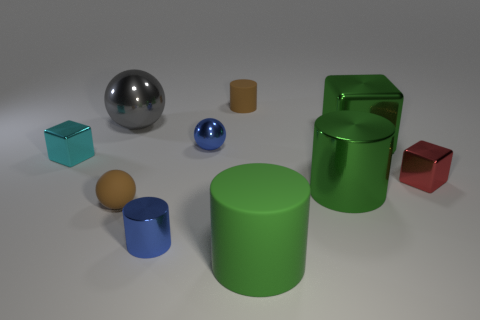Subtract all brown cylinders. How many cylinders are left? 3 Subtract all brown cylinders. How many cylinders are left? 3 Subtract all cylinders. How many objects are left? 6 Subtract 2 blocks. How many blocks are left? 1 Subtract all large blocks. Subtract all blue shiny things. How many objects are left? 7 Add 5 green objects. How many green objects are left? 8 Add 4 blue balls. How many blue balls exist? 5 Subtract 0 gray cubes. How many objects are left? 10 Subtract all red blocks. Subtract all blue cylinders. How many blocks are left? 2 Subtract all gray cylinders. How many yellow cubes are left? 0 